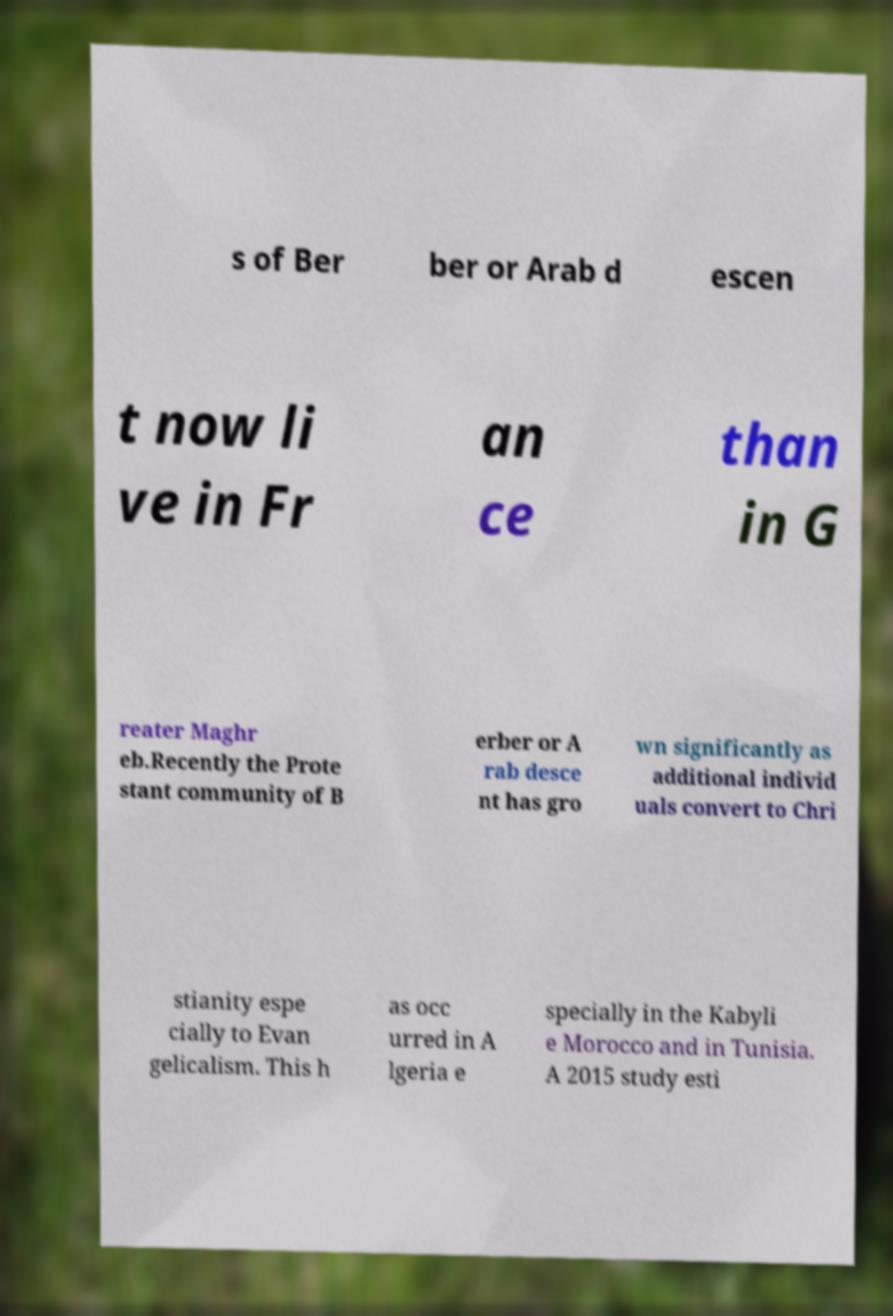Can you read and provide the text displayed in the image?This photo seems to have some interesting text. Can you extract and type it out for me? s of Ber ber or Arab d escen t now li ve in Fr an ce than in G reater Maghr eb.Recently the Prote stant community of B erber or A rab desce nt has gro wn significantly as additional individ uals convert to Chri stianity espe cially to Evan gelicalism. This h as occ urred in A lgeria e specially in the Kabyli e Morocco and in Tunisia. A 2015 study esti 